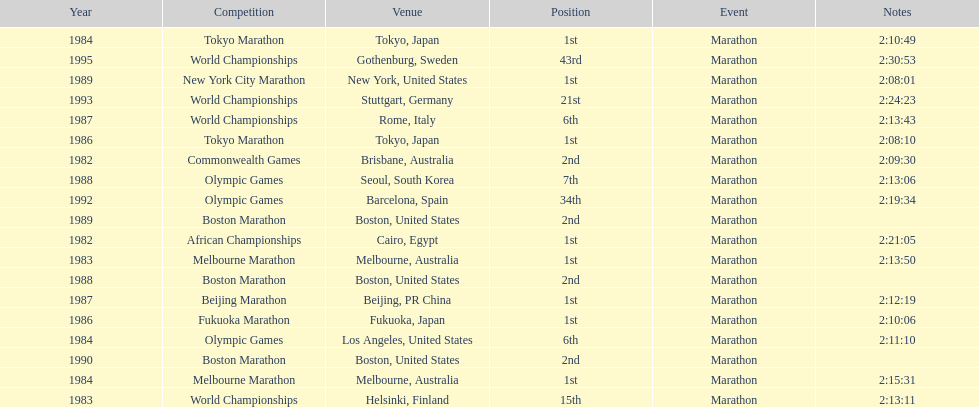What was the first marathon juma ikangaa won? 1982 African Championships. 